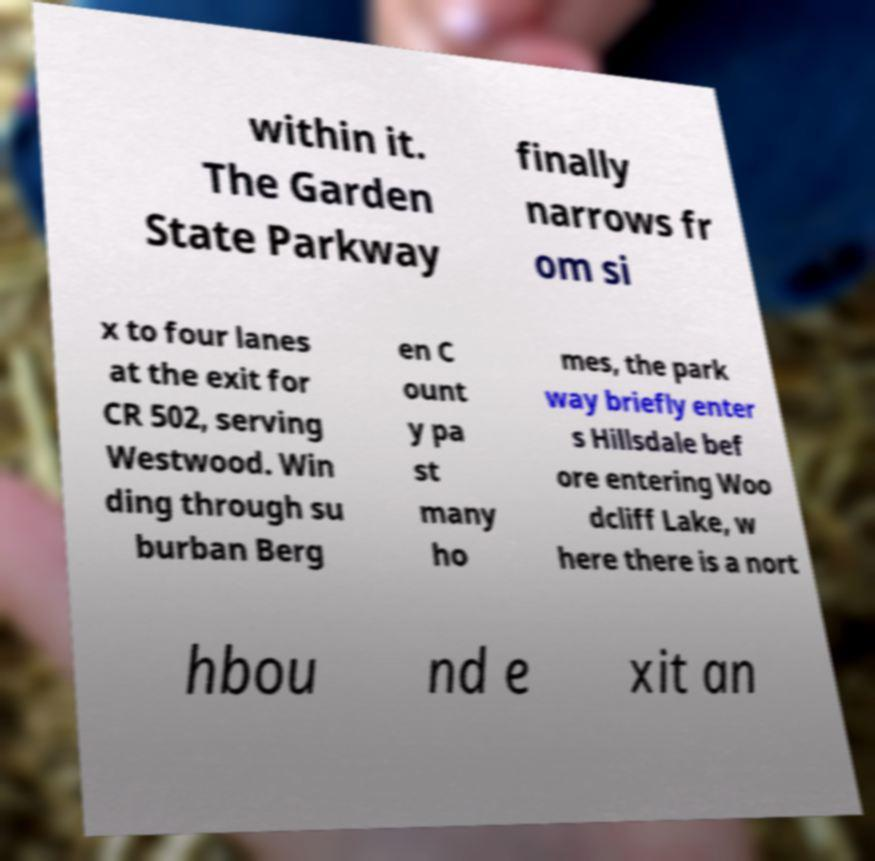Please identify and transcribe the text found in this image. within it. The Garden State Parkway finally narrows fr om si x to four lanes at the exit for CR 502, serving Westwood. Win ding through su burban Berg en C ount y pa st many ho mes, the park way briefly enter s Hillsdale bef ore entering Woo dcliff Lake, w here there is a nort hbou nd e xit an 